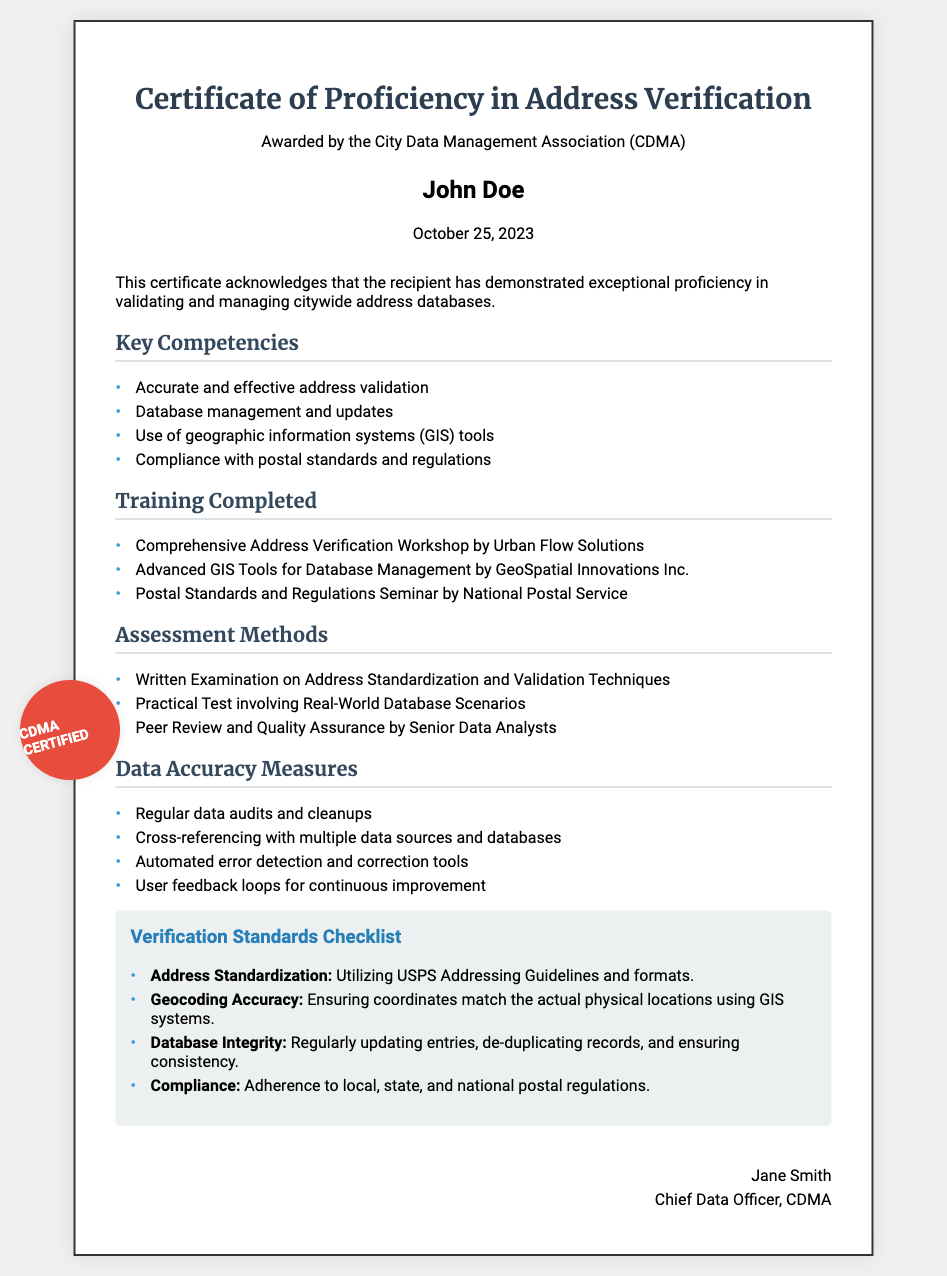What is the title of the certificate? The title is presented prominently at the top of the document under the header section.
Answer: Certificate of Proficiency in Address Verification Who awarded the certificate? The awarding body is mentioned directly below the certificate title.
Answer: City Data Management Association (CDMA) Who is the recipient of the certificate? The recipient's name is bold and emphasized in the document.
Answer: John Doe What date was the certificate awarded? The date is specified right below the recipient's name in the document.
Answer: October 25, 2023 What is one of the key competencies listed? The document lists multiple key competencies within a designated section.
Answer: Accurate and effective address validation How many training programs are listed? The number of training programs can be counted under the "Training Completed" section.
Answer: Three What assessment method involves a written examination? The document details specific assessment methods, one of which is as follows.
Answer: Written Examination on Address Standardization and Validation Techniques Name one measure included in the Data Accuracy Measures. The measures aim to maintain data accuracy and integrity; one can be identified in the list.
Answer: Regular data audits and cleanups What is the verification standard related to database integrity? The document includes a standard checklist that outlines specifics, including database integrity measures.
Answer: Regularly updating entries, de-duplicating records, and ensuring consistency 